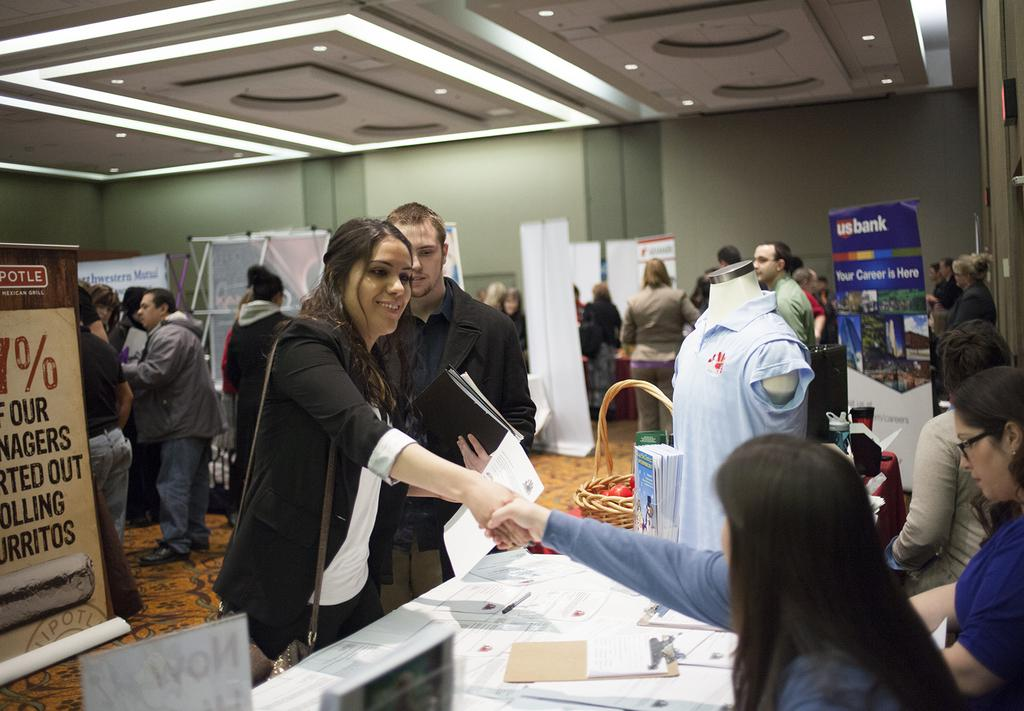<image>
Create a compact narrative representing the image presented. A US Bank display advertises that one should start a career there. 